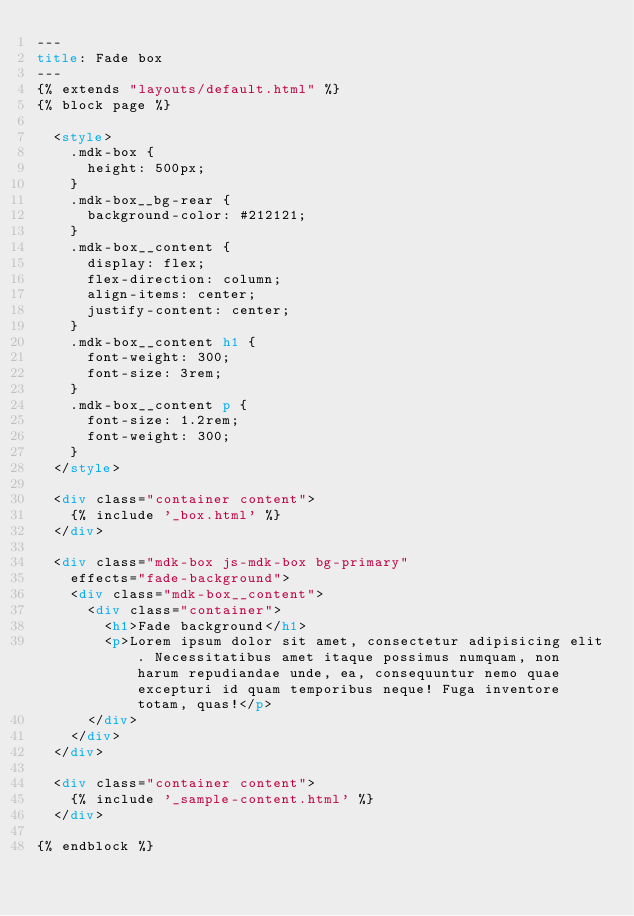<code> <loc_0><loc_0><loc_500><loc_500><_HTML_>---
title: Fade box
---
{% extends "layouts/default.html" %}
{% block page %}

  <style>
    .mdk-box {
      height: 500px;
    }
    .mdk-box__bg-rear {
      background-color: #212121;
    }
    .mdk-box__content {
      display: flex;
      flex-direction: column;
      align-items: center;
      justify-content: center;
    }
    .mdk-box__content h1 {
      font-weight: 300;
      font-size: 3rem;
    }
    .mdk-box__content p {
      font-size: 1.2rem;
      font-weight: 300;
    }
  </style>

  <div class="container content">
    {% include '_box.html' %}
  </div>

  <div class="mdk-box js-mdk-box bg-primary" 
    effects="fade-background">
    <div class="mdk-box__content">
      <div class="container">
        <h1>Fade background</h1>
        <p>Lorem ipsum dolor sit amet, consectetur adipisicing elit. Necessitatibus amet itaque possimus numquam, non harum repudiandae unde, ea, consequuntur nemo quae excepturi id quam temporibus neque! Fuga inventore totam, quas!</p>
      </div>
    </div>
  </div>

  <div class="container content">
    {% include '_sample-content.html' %}
  </div>

{% endblock %}</code> 